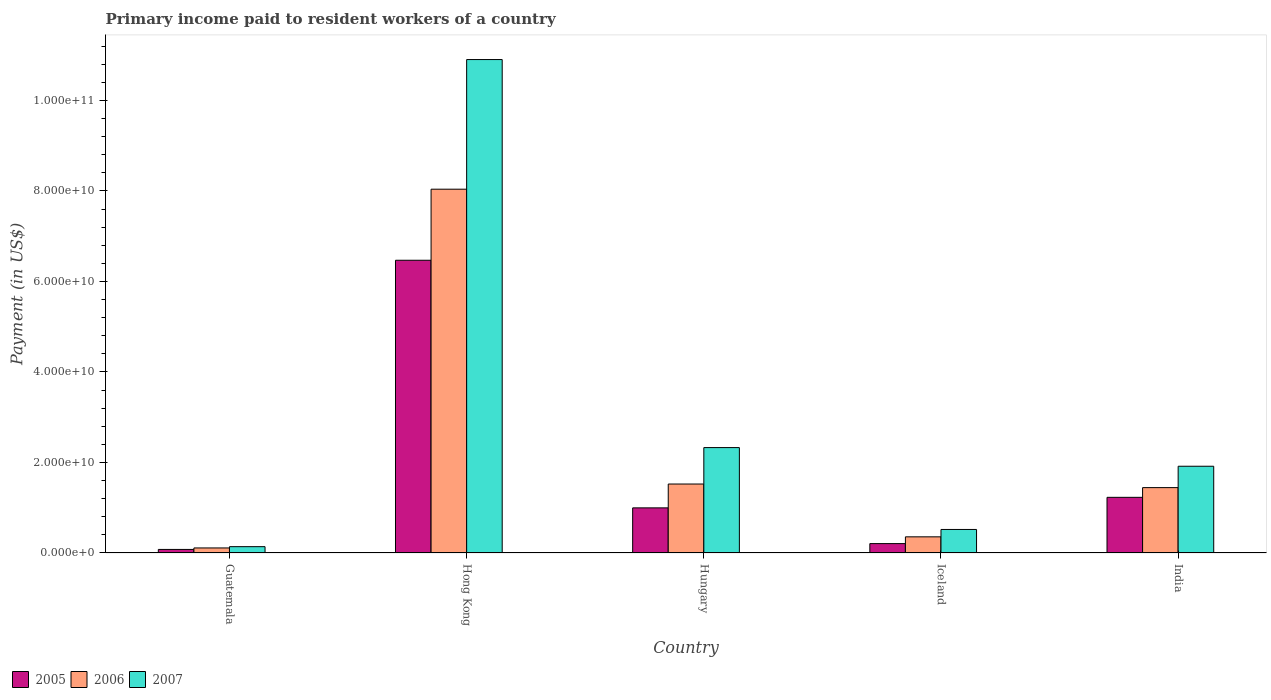How many groups of bars are there?
Offer a very short reply. 5. Are the number of bars on each tick of the X-axis equal?
Provide a succinct answer. Yes. How many bars are there on the 4th tick from the left?
Your answer should be compact. 3. How many bars are there on the 3rd tick from the right?
Provide a succinct answer. 3. What is the label of the 1st group of bars from the left?
Provide a short and direct response. Guatemala. In how many cases, is the number of bars for a given country not equal to the number of legend labels?
Provide a succinct answer. 0. What is the amount paid to workers in 2006 in Hungary?
Your answer should be very brief. 1.52e+1. Across all countries, what is the maximum amount paid to workers in 2007?
Keep it short and to the point. 1.09e+11. Across all countries, what is the minimum amount paid to workers in 2005?
Your answer should be very brief. 7.86e+08. In which country was the amount paid to workers in 2006 maximum?
Your response must be concise. Hong Kong. In which country was the amount paid to workers in 2006 minimum?
Your answer should be very brief. Guatemala. What is the total amount paid to workers in 2006 in the graph?
Your answer should be very brief. 1.15e+11. What is the difference between the amount paid to workers in 2005 in Guatemala and that in India?
Provide a succinct answer. -1.15e+1. What is the difference between the amount paid to workers in 2007 in India and the amount paid to workers in 2005 in Hungary?
Your answer should be compact. 9.20e+09. What is the average amount paid to workers in 2005 per country?
Your answer should be compact. 1.80e+1. What is the difference between the amount paid to workers of/in 2005 and amount paid to workers of/in 2007 in Hong Kong?
Your response must be concise. -4.43e+1. In how many countries, is the amount paid to workers in 2007 greater than 68000000000 US$?
Your answer should be compact. 1. What is the ratio of the amount paid to workers in 2006 in Hungary to that in Iceland?
Provide a succinct answer. 4.27. Is the difference between the amount paid to workers in 2005 in Guatemala and Hong Kong greater than the difference between the amount paid to workers in 2007 in Guatemala and Hong Kong?
Give a very brief answer. Yes. What is the difference between the highest and the second highest amount paid to workers in 2006?
Ensure brevity in your answer.  -7.92e+08. What is the difference between the highest and the lowest amount paid to workers in 2006?
Make the answer very short. 7.93e+1. In how many countries, is the amount paid to workers in 2007 greater than the average amount paid to workers in 2007 taken over all countries?
Ensure brevity in your answer.  1. What does the 1st bar from the left in Hong Kong represents?
Your answer should be compact. 2005. What does the 3rd bar from the right in Hungary represents?
Offer a very short reply. 2005. How many bars are there?
Your answer should be compact. 15. Are all the bars in the graph horizontal?
Ensure brevity in your answer.  No. Are the values on the major ticks of Y-axis written in scientific E-notation?
Offer a terse response. Yes. Where does the legend appear in the graph?
Your answer should be very brief. Bottom left. What is the title of the graph?
Your response must be concise. Primary income paid to resident workers of a country. What is the label or title of the Y-axis?
Provide a succinct answer. Payment (in US$). What is the Payment (in US$) of 2005 in Guatemala?
Your answer should be compact. 7.86e+08. What is the Payment (in US$) in 2006 in Guatemala?
Keep it short and to the point. 1.12e+09. What is the Payment (in US$) of 2007 in Guatemala?
Make the answer very short. 1.40e+09. What is the Payment (in US$) of 2005 in Hong Kong?
Make the answer very short. 6.47e+1. What is the Payment (in US$) in 2006 in Hong Kong?
Make the answer very short. 8.04e+1. What is the Payment (in US$) of 2007 in Hong Kong?
Keep it short and to the point. 1.09e+11. What is the Payment (in US$) in 2005 in Hungary?
Provide a short and direct response. 9.97e+09. What is the Payment (in US$) of 2006 in Hungary?
Offer a terse response. 1.52e+1. What is the Payment (in US$) of 2007 in Hungary?
Provide a succinct answer. 2.33e+1. What is the Payment (in US$) in 2005 in Iceland?
Offer a terse response. 2.07e+09. What is the Payment (in US$) of 2006 in Iceland?
Ensure brevity in your answer.  3.57e+09. What is the Payment (in US$) in 2007 in Iceland?
Provide a succinct answer. 5.20e+09. What is the Payment (in US$) of 2005 in India?
Your answer should be compact. 1.23e+1. What is the Payment (in US$) of 2006 in India?
Provide a succinct answer. 1.44e+1. What is the Payment (in US$) of 2007 in India?
Give a very brief answer. 1.92e+1. Across all countries, what is the maximum Payment (in US$) in 2005?
Your response must be concise. 6.47e+1. Across all countries, what is the maximum Payment (in US$) in 2006?
Ensure brevity in your answer.  8.04e+1. Across all countries, what is the maximum Payment (in US$) of 2007?
Make the answer very short. 1.09e+11. Across all countries, what is the minimum Payment (in US$) of 2005?
Provide a succinct answer. 7.86e+08. Across all countries, what is the minimum Payment (in US$) of 2006?
Offer a very short reply. 1.12e+09. Across all countries, what is the minimum Payment (in US$) of 2007?
Make the answer very short. 1.40e+09. What is the total Payment (in US$) in 2005 in the graph?
Your response must be concise. 8.98e+1. What is the total Payment (in US$) in 2006 in the graph?
Your response must be concise. 1.15e+11. What is the total Payment (in US$) of 2007 in the graph?
Offer a very short reply. 1.58e+11. What is the difference between the Payment (in US$) of 2005 in Guatemala and that in Hong Kong?
Your answer should be compact. -6.39e+1. What is the difference between the Payment (in US$) in 2006 in Guatemala and that in Hong Kong?
Your response must be concise. -7.93e+1. What is the difference between the Payment (in US$) in 2007 in Guatemala and that in Hong Kong?
Your answer should be compact. -1.08e+11. What is the difference between the Payment (in US$) in 2005 in Guatemala and that in Hungary?
Make the answer very short. -9.18e+09. What is the difference between the Payment (in US$) in 2006 in Guatemala and that in Hungary?
Give a very brief answer. -1.41e+1. What is the difference between the Payment (in US$) in 2007 in Guatemala and that in Hungary?
Keep it short and to the point. -2.19e+1. What is the difference between the Payment (in US$) of 2005 in Guatemala and that in Iceland?
Your response must be concise. -1.29e+09. What is the difference between the Payment (in US$) in 2006 in Guatemala and that in Iceland?
Offer a terse response. -2.45e+09. What is the difference between the Payment (in US$) of 2007 in Guatemala and that in Iceland?
Your response must be concise. -3.80e+09. What is the difference between the Payment (in US$) in 2005 in Guatemala and that in India?
Give a very brief answer. -1.15e+1. What is the difference between the Payment (in US$) of 2006 in Guatemala and that in India?
Provide a succinct answer. -1.33e+1. What is the difference between the Payment (in US$) in 2007 in Guatemala and that in India?
Your response must be concise. -1.78e+1. What is the difference between the Payment (in US$) in 2005 in Hong Kong and that in Hungary?
Offer a very short reply. 5.47e+1. What is the difference between the Payment (in US$) in 2006 in Hong Kong and that in Hungary?
Provide a succinct answer. 6.51e+1. What is the difference between the Payment (in US$) in 2007 in Hong Kong and that in Hungary?
Make the answer very short. 8.57e+1. What is the difference between the Payment (in US$) of 2005 in Hong Kong and that in Iceland?
Provide a succinct answer. 6.26e+1. What is the difference between the Payment (in US$) in 2006 in Hong Kong and that in Iceland?
Offer a terse response. 7.68e+1. What is the difference between the Payment (in US$) of 2007 in Hong Kong and that in Iceland?
Provide a succinct answer. 1.04e+11. What is the difference between the Payment (in US$) in 2005 in Hong Kong and that in India?
Your answer should be very brief. 5.24e+1. What is the difference between the Payment (in US$) in 2006 in Hong Kong and that in India?
Ensure brevity in your answer.  6.59e+1. What is the difference between the Payment (in US$) in 2007 in Hong Kong and that in India?
Offer a very short reply. 8.99e+1. What is the difference between the Payment (in US$) of 2005 in Hungary and that in Iceland?
Offer a very short reply. 7.90e+09. What is the difference between the Payment (in US$) of 2006 in Hungary and that in Iceland?
Provide a short and direct response. 1.17e+1. What is the difference between the Payment (in US$) in 2007 in Hungary and that in Iceland?
Make the answer very short. 1.81e+1. What is the difference between the Payment (in US$) of 2005 in Hungary and that in India?
Your answer should be very brief. -2.33e+09. What is the difference between the Payment (in US$) of 2006 in Hungary and that in India?
Ensure brevity in your answer.  7.92e+08. What is the difference between the Payment (in US$) in 2007 in Hungary and that in India?
Provide a short and direct response. 4.12e+09. What is the difference between the Payment (in US$) of 2005 in Iceland and that in India?
Your answer should be very brief. -1.02e+1. What is the difference between the Payment (in US$) in 2006 in Iceland and that in India?
Offer a terse response. -1.09e+1. What is the difference between the Payment (in US$) of 2007 in Iceland and that in India?
Make the answer very short. -1.40e+1. What is the difference between the Payment (in US$) of 2005 in Guatemala and the Payment (in US$) of 2006 in Hong Kong?
Provide a succinct answer. -7.96e+1. What is the difference between the Payment (in US$) of 2005 in Guatemala and the Payment (in US$) of 2007 in Hong Kong?
Ensure brevity in your answer.  -1.08e+11. What is the difference between the Payment (in US$) in 2006 in Guatemala and the Payment (in US$) in 2007 in Hong Kong?
Provide a succinct answer. -1.08e+11. What is the difference between the Payment (in US$) in 2005 in Guatemala and the Payment (in US$) in 2006 in Hungary?
Ensure brevity in your answer.  -1.45e+1. What is the difference between the Payment (in US$) of 2005 in Guatemala and the Payment (in US$) of 2007 in Hungary?
Give a very brief answer. -2.25e+1. What is the difference between the Payment (in US$) in 2006 in Guatemala and the Payment (in US$) in 2007 in Hungary?
Your response must be concise. -2.22e+1. What is the difference between the Payment (in US$) of 2005 in Guatemala and the Payment (in US$) of 2006 in Iceland?
Offer a very short reply. -2.78e+09. What is the difference between the Payment (in US$) of 2005 in Guatemala and the Payment (in US$) of 2007 in Iceland?
Provide a succinct answer. -4.41e+09. What is the difference between the Payment (in US$) in 2006 in Guatemala and the Payment (in US$) in 2007 in Iceland?
Provide a succinct answer. -4.08e+09. What is the difference between the Payment (in US$) in 2005 in Guatemala and the Payment (in US$) in 2006 in India?
Your answer should be very brief. -1.37e+1. What is the difference between the Payment (in US$) in 2005 in Guatemala and the Payment (in US$) in 2007 in India?
Offer a very short reply. -1.84e+1. What is the difference between the Payment (in US$) in 2006 in Guatemala and the Payment (in US$) in 2007 in India?
Offer a terse response. -1.81e+1. What is the difference between the Payment (in US$) of 2005 in Hong Kong and the Payment (in US$) of 2006 in Hungary?
Your response must be concise. 4.94e+1. What is the difference between the Payment (in US$) in 2005 in Hong Kong and the Payment (in US$) in 2007 in Hungary?
Your answer should be compact. 4.14e+1. What is the difference between the Payment (in US$) of 2006 in Hong Kong and the Payment (in US$) of 2007 in Hungary?
Ensure brevity in your answer.  5.71e+1. What is the difference between the Payment (in US$) of 2005 in Hong Kong and the Payment (in US$) of 2006 in Iceland?
Your response must be concise. 6.11e+1. What is the difference between the Payment (in US$) in 2005 in Hong Kong and the Payment (in US$) in 2007 in Iceland?
Provide a short and direct response. 5.95e+1. What is the difference between the Payment (in US$) of 2006 in Hong Kong and the Payment (in US$) of 2007 in Iceland?
Provide a short and direct response. 7.52e+1. What is the difference between the Payment (in US$) in 2005 in Hong Kong and the Payment (in US$) in 2006 in India?
Your answer should be compact. 5.02e+1. What is the difference between the Payment (in US$) of 2005 in Hong Kong and the Payment (in US$) of 2007 in India?
Make the answer very short. 4.55e+1. What is the difference between the Payment (in US$) in 2006 in Hong Kong and the Payment (in US$) in 2007 in India?
Make the answer very short. 6.12e+1. What is the difference between the Payment (in US$) of 2005 in Hungary and the Payment (in US$) of 2006 in Iceland?
Give a very brief answer. 6.40e+09. What is the difference between the Payment (in US$) of 2005 in Hungary and the Payment (in US$) of 2007 in Iceland?
Ensure brevity in your answer.  4.77e+09. What is the difference between the Payment (in US$) of 2006 in Hungary and the Payment (in US$) of 2007 in Iceland?
Offer a terse response. 1.00e+1. What is the difference between the Payment (in US$) of 2005 in Hungary and the Payment (in US$) of 2006 in India?
Give a very brief answer. -4.47e+09. What is the difference between the Payment (in US$) in 2005 in Hungary and the Payment (in US$) in 2007 in India?
Your answer should be compact. -9.20e+09. What is the difference between the Payment (in US$) in 2006 in Hungary and the Payment (in US$) in 2007 in India?
Make the answer very short. -3.93e+09. What is the difference between the Payment (in US$) of 2005 in Iceland and the Payment (in US$) of 2006 in India?
Provide a short and direct response. -1.24e+1. What is the difference between the Payment (in US$) in 2005 in Iceland and the Payment (in US$) in 2007 in India?
Ensure brevity in your answer.  -1.71e+1. What is the difference between the Payment (in US$) of 2006 in Iceland and the Payment (in US$) of 2007 in India?
Your answer should be compact. -1.56e+1. What is the average Payment (in US$) in 2005 per country?
Make the answer very short. 1.80e+1. What is the average Payment (in US$) of 2006 per country?
Your answer should be very brief. 2.29e+1. What is the average Payment (in US$) in 2007 per country?
Provide a short and direct response. 3.16e+1. What is the difference between the Payment (in US$) in 2005 and Payment (in US$) in 2006 in Guatemala?
Your response must be concise. -3.28e+08. What is the difference between the Payment (in US$) of 2005 and Payment (in US$) of 2007 in Guatemala?
Offer a very short reply. -6.12e+08. What is the difference between the Payment (in US$) in 2006 and Payment (in US$) in 2007 in Guatemala?
Your answer should be very brief. -2.84e+08. What is the difference between the Payment (in US$) in 2005 and Payment (in US$) in 2006 in Hong Kong?
Your response must be concise. -1.57e+1. What is the difference between the Payment (in US$) in 2005 and Payment (in US$) in 2007 in Hong Kong?
Your response must be concise. -4.43e+1. What is the difference between the Payment (in US$) of 2006 and Payment (in US$) of 2007 in Hong Kong?
Make the answer very short. -2.86e+1. What is the difference between the Payment (in US$) of 2005 and Payment (in US$) of 2006 in Hungary?
Provide a short and direct response. -5.27e+09. What is the difference between the Payment (in US$) in 2005 and Payment (in US$) in 2007 in Hungary?
Your answer should be compact. -1.33e+1. What is the difference between the Payment (in US$) in 2006 and Payment (in US$) in 2007 in Hungary?
Make the answer very short. -8.05e+09. What is the difference between the Payment (in US$) in 2005 and Payment (in US$) in 2006 in Iceland?
Offer a very short reply. -1.50e+09. What is the difference between the Payment (in US$) of 2005 and Payment (in US$) of 2007 in Iceland?
Your answer should be compact. -3.13e+09. What is the difference between the Payment (in US$) in 2006 and Payment (in US$) in 2007 in Iceland?
Make the answer very short. -1.63e+09. What is the difference between the Payment (in US$) of 2005 and Payment (in US$) of 2006 in India?
Your answer should be very brief. -2.15e+09. What is the difference between the Payment (in US$) of 2005 and Payment (in US$) of 2007 in India?
Provide a succinct answer. -6.87e+09. What is the difference between the Payment (in US$) of 2006 and Payment (in US$) of 2007 in India?
Make the answer very short. -4.72e+09. What is the ratio of the Payment (in US$) in 2005 in Guatemala to that in Hong Kong?
Offer a very short reply. 0.01. What is the ratio of the Payment (in US$) of 2006 in Guatemala to that in Hong Kong?
Provide a succinct answer. 0.01. What is the ratio of the Payment (in US$) in 2007 in Guatemala to that in Hong Kong?
Offer a terse response. 0.01. What is the ratio of the Payment (in US$) of 2005 in Guatemala to that in Hungary?
Ensure brevity in your answer.  0.08. What is the ratio of the Payment (in US$) in 2006 in Guatemala to that in Hungary?
Provide a short and direct response. 0.07. What is the ratio of the Payment (in US$) in 2007 in Guatemala to that in Hungary?
Provide a succinct answer. 0.06. What is the ratio of the Payment (in US$) in 2005 in Guatemala to that in Iceland?
Provide a succinct answer. 0.38. What is the ratio of the Payment (in US$) in 2006 in Guatemala to that in Iceland?
Give a very brief answer. 0.31. What is the ratio of the Payment (in US$) in 2007 in Guatemala to that in Iceland?
Provide a succinct answer. 0.27. What is the ratio of the Payment (in US$) in 2005 in Guatemala to that in India?
Your answer should be very brief. 0.06. What is the ratio of the Payment (in US$) in 2006 in Guatemala to that in India?
Make the answer very short. 0.08. What is the ratio of the Payment (in US$) of 2007 in Guatemala to that in India?
Provide a short and direct response. 0.07. What is the ratio of the Payment (in US$) of 2005 in Hong Kong to that in Hungary?
Your answer should be very brief. 6.49. What is the ratio of the Payment (in US$) in 2006 in Hong Kong to that in Hungary?
Your answer should be very brief. 5.28. What is the ratio of the Payment (in US$) of 2007 in Hong Kong to that in Hungary?
Your response must be concise. 4.68. What is the ratio of the Payment (in US$) of 2005 in Hong Kong to that in Iceland?
Make the answer very short. 31.18. What is the ratio of the Payment (in US$) of 2006 in Hong Kong to that in Iceland?
Provide a succinct answer. 22.52. What is the ratio of the Payment (in US$) in 2007 in Hong Kong to that in Iceland?
Offer a very short reply. 20.97. What is the ratio of the Payment (in US$) in 2005 in Hong Kong to that in India?
Ensure brevity in your answer.  5.26. What is the ratio of the Payment (in US$) of 2006 in Hong Kong to that in India?
Your answer should be very brief. 5.56. What is the ratio of the Payment (in US$) of 2007 in Hong Kong to that in India?
Give a very brief answer. 5.69. What is the ratio of the Payment (in US$) in 2005 in Hungary to that in Iceland?
Your response must be concise. 4.81. What is the ratio of the Payment (in US$) in 2006 in Hungary to that in Iceland?
Provide a short and direct response. 4.27. What is the ratio of the Payment (in US$) of 2007 in Hungary to that in Iceland?
Provide a succinct answer. 4.48. What is the ratio of the Payment (in US$) of 2005 in Hungary to that in India?
Make the answer very short. 0.81. What is the ratio of the Payment (in US$) in 2006 in Hungary to that in India?
Your answer should be very brief. 1.05. What is the ratio of the Payment (in US$) of 2007 in Hungary to that in India?
Your response must be concise. 1.22. What is the ratio of the Payment (in US$) of 2005 in Iceland to that in India?
Your answer should be compact. 0.17. What is the ratio of the Payment (in US$) of 2006 in Iceland to that in India?
Your answer should be very brief. 0.25. What is the ratio of the Payment (in US$) in 2007 in Iceland to that in India?
Your answer should be compact. 0.27. What is the difference between the highest and the second highest Payment (in US$) of 2005?
Offer a very short reply. 5.24e+1. What is the difference between the highest and the second highest Payment (in US$) in 2006?
Offer a terse response. 6.51e+1. What is the difference between the highest and the second highest Payment (in US$) of 2007?
Provide a short and direct response. 8.57e+1. What is the difference between the highest and the lowest Payment (in US$) in 2005?
Give a very brief answer. 6.39e+1. What is the difference between the highest and the lowest Payment (in US$) of 2006?
Offer a very short reply. 7.93e+1. What is the difference between the highest and the lowest Payment (in US$) in 2007?
Offer a terse response. 1.08e+11. 